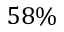Convert formula to latex. <formula><loc_0><loc_0><loc_500><loc_500>5 8 \%</formula> 